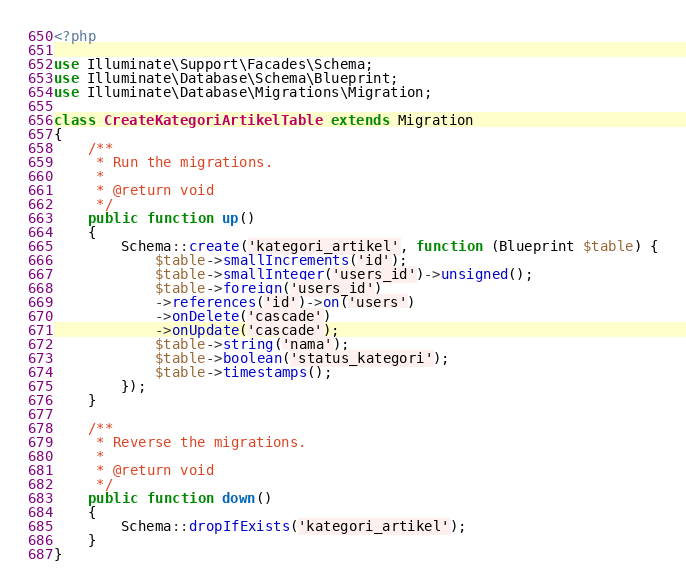<code> <loc_0><loc_0><loc_500><loc_500><_PHP_><?php

use Illuminate\Support\Facades\Schema;
use Illuminate\Database\Schema\Blueprint;
use Illuminate\Database\Migrations\Migration;

class CreateKategoriArtikelTable extends Migration
{
    /**
     * Run the migrations.
     *
     * @return void
     */
    public function up()
    {
        Schema::create('kategori_artikel', function (Blueprint $table) {
            $table->smallIncrements('id');
            $table->smallInteger('users_id')->unsigned();
            $table->foreign('users_id')
            ->references('id')->on('users')
            ->onDelete('cascade')
            ->onUpdate('cascade');
            $table->string('nama');
            $table->boolean('status_kategori');
            $table->timestamps();
        });
    }

    /**
     * Reverse the migrations.
     *
     * @return void
     */
    public function down()
    {
        Schema::dropIfExists('kategori_artikel');
    }
}
</code> 